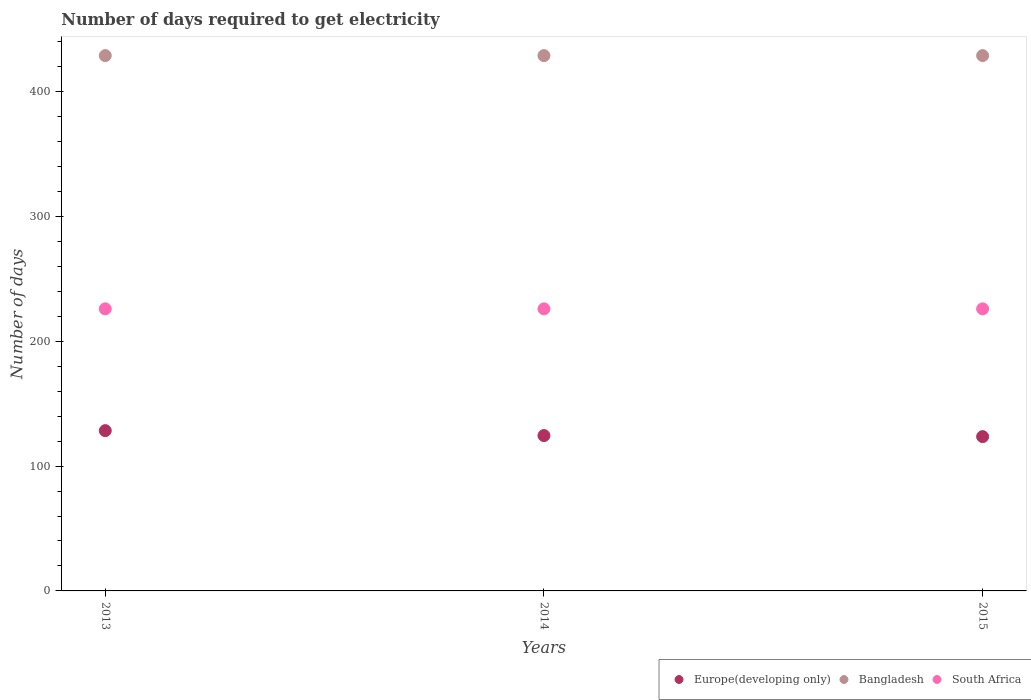How many different coloured dotlines are there?
Provide a short and direct response. 3. What is the number of days required to get electricity in in South Africa in 2013?
Offer a very short reply. 226. Across all years, what is the maximum number of days required to get electricity in in Europe(developing only)?
Provide a succinct answer. 128.42. Across all years, what is the minimum number of days required to get electricity in in Europe(developing only)?
Offer a terse response. 123.63. In which year was the number of days required to get electricity in in South Africa minimum?
Provide a short and direct response. 2013. What is the total number of days required to get electricity in in Europe(developing only) in the graph?
Keep it short and to the point. 376.53. What is the difference between the number of days required to get electricity in in Europe(developing only) in 2015 and the number of days required to get electricity in in Bangladesh in 2014?
Provide a succinct answer. -305.27. What is the average number of days required to get electricity in in Bangladesh per year?
Provide a short and direct response. 428.9. In the year 2015, what is the difference between the number of days required to get electricity in in Bangladesh and number of days required to get electricity in in Europe(developing only)?
Ensure brevity in your answer.  305.27. In how many years, is the number of days required to get electricity in in Europe(developing only) greater than 220 days?
Your answer should be very brief. 0. What is the ratio of the number of days required to get electricity in in South Africa in 2014 to that in 2015?
Ensure brevity in your answer.  1. Is the number of days required to get electricity in in Europe(developing only) in 2014 less than that in 2015?
Ensure brevity in your answer.  No. What is the difference between the highest and the lowest number of days required to get electricity in in Europe(developing only)?
Make the answer very short. 4.79. In how many years, is the number of days required to get electricity in in Bangladesh greater than the average number of days required to get electricity in in Bangladesh taken over all years?
Your response must be concise. 3. Is the sum of the number of days required to get electricity in in South Africa in 2014 and 2015 greater than the maximum number of days required to get electricity in in Europe(developing only) across all years?
Offer a very short reply. Yes. Is it the case that in every year, the sum of the number of days required to get electricity in in Europe(developing only) and number of days required to get electricity in in Bangladesh  is greater than the number of days required to get electricity in in South Africa?
Your response must be concise. Yes. Is the number of days required to get electricity in in Bangladesh strictly less than the number of days required to get electricity in in Europe(developing only) over the years?
Give a very brief answer. No. What is the difference between two consecutive major ticks on the Y-axis?
Ensure brevity in your answer.  100. Are the values on the major ticks of Y-axis written in scientific E-notation?
Your answer should be very brief. No. Does the graph contain any zero values?
Provide a succinct answer. No. How many legend labels are there?
Ensure brevity in your answer.  3. How are the legend labels stacked?
Ensure brevity in your answer.  Horizontal. What is the title of the graph?
Offer a terse response. Number of days required to get electricity. Does "Bosnia and Herzegovina" appear as one of the legend labels in the graph?
Your answer should be very brief. No. What is the label or title of the X-axis?
Keep it short and to the point. Years. What is the label or title of the Y-axis?
Ensure brevity in your answer.  Number of days. What is the Number of days of Europe(developing only) in 2013?
Offer a very short reply. 128.42. What is the Number of days of Bangladesh in 2013?
Offer a very short reply. 428.9. What is the Number of days of South Africa in 2013?
Provide a succinct answer. 226. What is the Number of days of Europe(developing only) in 2014?
Your response must be concise. 124.47. What is the Number of days in Bangladesh in 2014?
Keep it short and to the point. 428.9. What is the Number of days of South Africa in 2014?
Offer a terse response. 226. What is the Number of days in Europe(developing only) in 2015?
Provide a short and direct response. 123.63. What is the Number of days in Bangladesh in 2015?
Offer a very short reply. 428.9. What is the Number of days of South Africa in 2015?
Provide a short and direct response. 226. Across all years, what is the maximum Number of days of Europe(developing only)?
Offer a terse response. 128.42. Across all years, what is the maximum Number of days in Bangladesh?
Make the answer very short. 428.9. Across all years, what is the maximum Number of days of South Africa?
Provide a short and direct response. 226. Across all years, what is the minimum Number of days in Europe(developing only)?
Give a very brief answer. 123.63. Across all years, what is the minimum Number of days of Bangladesh?
Your answer should be very brief. 428.9. Across all years, what is the minimum Number of days in South Africa?
Give a very brief answer. 226. What is the total Number of days in Europe(developing only) in the graph?
Provide a succinct answer. 376.53. What is the total Number of days in Bangladesh in the graph?
Offer a very short reply. 1286.7. What is the total Number of days of South Africa in the graph?
Offer a very short reply. 678. What is the difference between the Number of days in Europe(developing only) in 2013 and that in 2014?
Provide a short and direct response. 3.95. What is the difference between the Number of days in Bangladesh in 2013 and that in 2014?
Offer a very short reply. 0. What is the difference between the Number of days of Europe(developing only) in 2013 and that in 2015?
Your answer should be very brief. 4.79. What is the difference between the Number of days of Europe(developing only) in 2014 and that in 2015?
Make the answer very short. 0.84. What is the difference between the Number of days of South Africa in 2014 and that in 2015?
Make the answer very short. 0. What is the difference between the Number of days of Europe(developing only) in 2013 and the Number of days of Bangladesh in 2014?
Your answer should be compact. -300.48. What is the difference between the Number of days of Europe(developing only) in 2013 and the Number of days of South Africa in 2014?
Your answer should be compact. -97.58. What is the difference between the Number of days of Bangladesh in 2013 and the Number of days of South Africa in 2014?
Your response must be concise. 202.9. What is the difference between the Number of days in Europe(developing only) in 2013 and the Number of days in Bangladesh in 2015?
Give a very brief answer. -300.48. What is the difference between the Number of days in Europe(developing only) in 2013 and the Number of days in South Africa in 2015?
Provide a short and direct response. -97.58. What is the difference between the Number of days of Bangladesh in 2013 and the Number of days of South Africa in 2015?
Provide a short and direct response. 202.9. What is the difference between the Number of days in Europe(developing only) in 2014 and the Number of days in Bangladesh in 2015?
Provide a short and direct response. -304.43. What is the difference between the Number of days of Europe(developing only) in 2014 and the Number of days of South Africa in 2015?
Offer a terse response. -101.53. What is the difference between the Number of days in Bangladesh in 2014 and the Number of days in South Africa in 2015?
Make the answer very short. 202.9. What is the average Number of days in Europe(developing only) per year?
Your answer should be compact. 125.51. What is the average Number of days of Bangladesh per year?
Keep it short and to the point. 428.9. What is the average Number of days of South Africa per year?
Offer a terse response. 226. In the year 2013, what is the difference between the Number of days of Europe(developing only) and Number of days of Bangladesh?
Your response must be concise. -300.48. In the year 2013, what is the difference between the Number of days in Europe(developing only) and Number of days in South Africa?
Keep it short and to the point. -97.58. In the year 2013, what is the difference between the Number of days in Bangladesh and Number of days in South Africa?
Provide a short and direct response. 202.9. In the year 2014, what is the difference between the Number of days in Europe(developing only) and Number of days in Bangladesh?
Your answer should be compact. -304.43. In the year 2014, what is the difference between the Number of days in Europe(developing only) and Number of days in South Africa?
Your answer should be compact. -101.53. In the year 2014, what is the difference between the Number of days in Bangladesh and Number of days in South Africa?
Keep it short and to the point. 202.9. In the year 2015, what is the difference between the Number of days of Europe(developing only) and Number of days of Bangladesh?
Offer a very short reply. -305.27. In the year 2015, what is the difference between the Number of days in Europe(developing only) and Number of days in South Africa?
Ensure brevity in your answer.  -102.37. In the year 2015, what is the difference between the Number of days of Bangladesh and Number of days of South Africa?
Provide a succinct answer. 202.9. What is the ratio of the Number of days in Europe(developing only) in 2013 to that in 2014?
Your response must be concise. 1.03. What is the ratio of the Number of days of Europe(developing only) in 2013 to that in 2015?
Keep it short and to the point. 1.04. What is the ratio of the Number of days in Bangladesh in 2013 to that in 2015?
Give a very brief answer. 1. What is the ratio of the Number of days in South Africa in 2013 to that in 2015?
Your answer should be very brief. 1. What is the ratio of the Number of days in Europe(developing only) in 2014 to that in 2015?
Give a very brief answer. 1.01. What is the ratio of the Number of days in Bangladesh in 2014 to that in 2015?
Your response must be concise. 1. What is the ratio of the Number of days in South Africa in 2014 to that in 2015?
Provide a short and direct response. 1. What is the difference between the highest and the second highest Number of days in Europe(developing only)?
Ensure brevity in your answer.  3.95. What is the difference between the highest and the second highest Number of days in Bangladesh?
Offer a terse response. 0. What is the difference between the highest and the second highest Number of days in South Africa?
Keep it short and to the point. 0. What is the difference between the highest and the lowest Number of days of Europe(developing only)?
Provide a succinct answer. 4.79. What is the difference between the highest and the lowest Number of days of South Africa?
Your answer should be very brief. 0. 